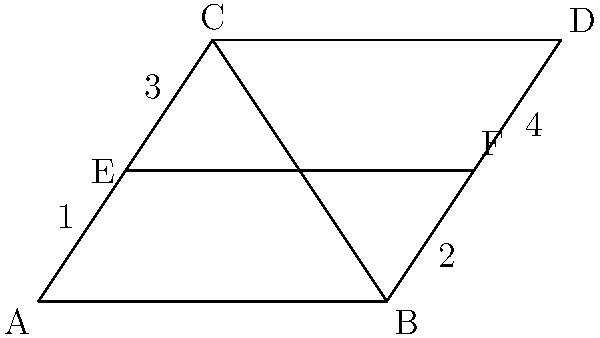In the system flowchart above, triangles ABC and BCD represent two different modules of an ICT system. If triangle ABC is congruent to triangle BCD, and the length of EF is 4 units, what is the length of BD? Let's approach this step-by-step:

1) Given that triangle ABC is congruent to triangle BCD, we know that all corresponding sides and angles are equal.

2) In congruent triangles, the altitude to the base is equal. Here, EF is parallel to AB and CD, and it bisects AC and BD.

3) This means that AE = EC and BF = FD.

4) Since EF is 4 units long, and it's parallel to AB and CD, we can conclude that AB = CD = 4 units.

5) Now, let's focus on triangle BCD. We know that BC = CD (from congruence) and CD = 4 units.

6) In an isosceles triangle, the altitude to the base bisects the base. This means that BF = FD = 2 units.

7) Now we have a right triangle BFD, where BF = 2 and FD = 2.

8) We can use the Pythagorean theorem to find BD:

   $$BD^2 = BF^2 + FD^2$$
   $$BD^2 = 2^2 + 2^2 = 4 + 4 = 8$$
   $$BD = \sqrt{8} = 2\sqrt{2}$$

Therefore, the length of BD is $2\sqrt{2}$ units.
Answer: $2\sqrt{2}$ units 